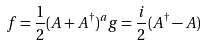Convert formula to latex. <formula><loc_0><loc_0><loc_500><loc_500>f = \frac { 1 } { 2 } ( A + A ^ { \dagger } ) ^ { a } g = \frac { i } { 2 } ( A ^ { \dagger } - A )</formula> 